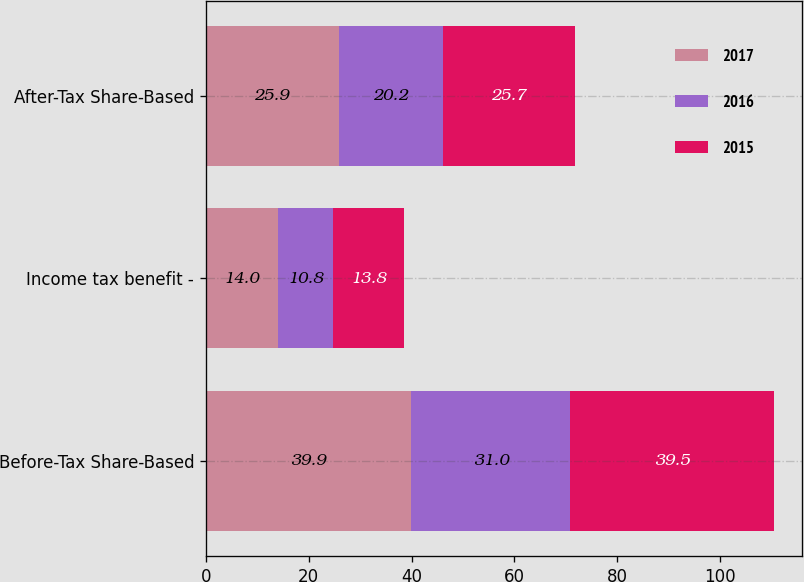Convert chart. <chart><loc_0><loc_0><loc_500><loc_500><stacked_bar_chart><ecel><fcel>Before-Tax Share-Based<fcel>Income tax benefit -<fcel>After-Tax Share-Based<nl><fcel>2017<fcel>39.9<fcel>14<fcel>25.9<nl><fcel>2016<fcel>31<fcel>10.8<fcel>20.2<nl><fcel>2015<fcel>39.5<fcel>13.8<fcel>25.7<nl></chart> 